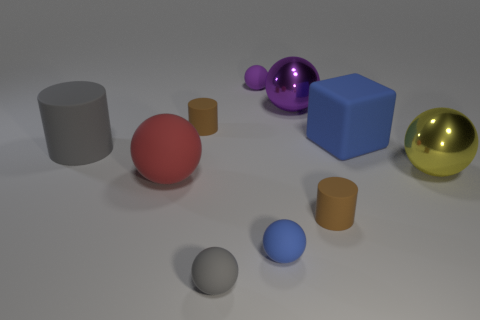What color is the large ball that is to the left of the thing behind the large purple metallic sphere?
Provide a succinct answer. Red. What shape is the gray rubber object that is the same size as the red rubber ball?
Give a very brief answer. Cylinder. Are there an equal number of big gray cylinders that are to the right of the large blue thing and brown matte cylinders?
Keep it short and to the point. No. What material is the cylinder behind the thing that is left of the big rubber object that is in front of the gray cylinder?
Your response must be concise. Rubber. What is the shape of the large red object that is the same material as the tiny purple object?
Offer a very short reply. Sphere. Is there anything else of the same color as the large rubber block?
Your answer should be compact. Yes. What number of blue rubber balls are behind the tiny cylinder that is in front of the tiny thing on the left side of the small gray rubber thing?
Offer a terse response. 0. What number of red objects are shiny cylinders or large shiny spheres?
Ensure brevity in your answer.  0. There is a purple shiny sphere; is its size the same as the brown cylinder in front of the big red rubber thing?
Make the answer very short. No. What is the material of the gray thing that is the same shape as the large red matte object?
Give a very brief answer. Rubber. 